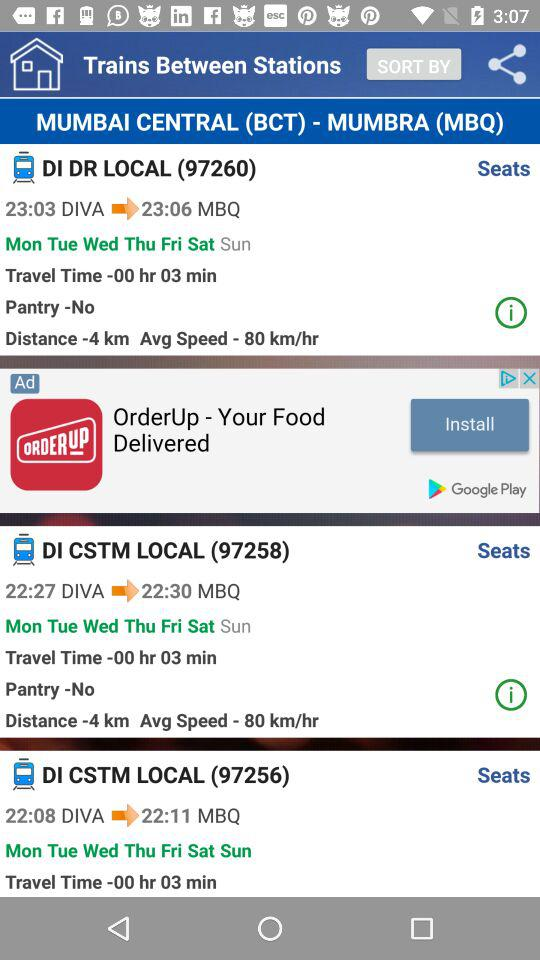How many trains are there between MUMBAI CENTRAL (BCT) and MUMBRA (MBQ)?
Answer the question using a single word or phrase. 3 